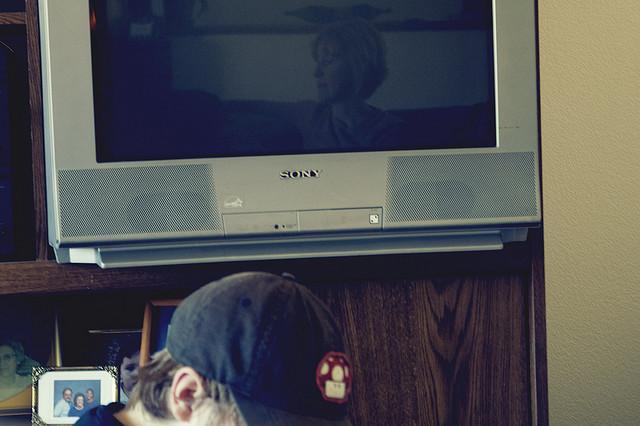How many people are in the picture in the background?
Give a very brief answer. 1. How many people are there?
Give a very brief answer. 2. 